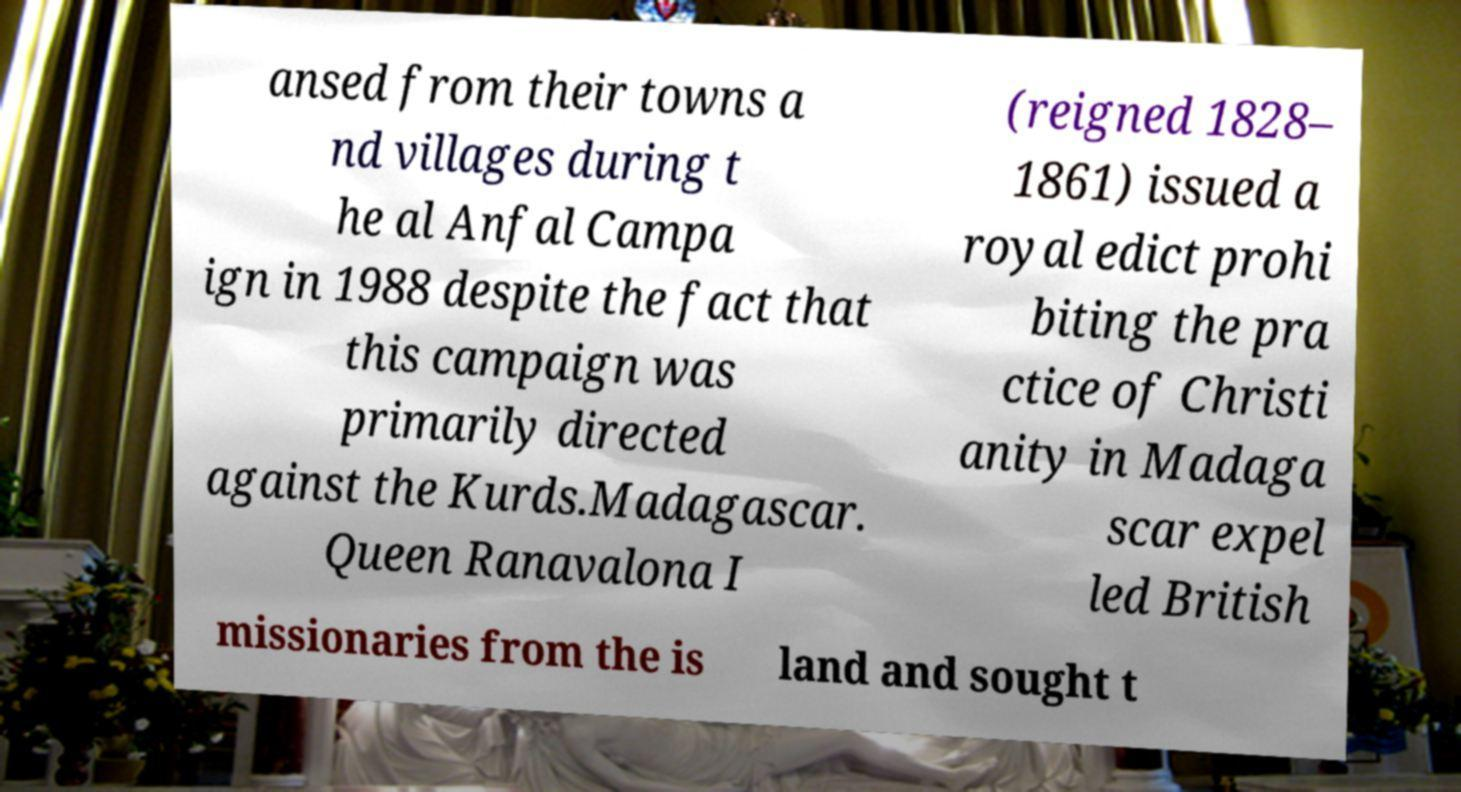For documentation purposes, I need the text within this image transcribed. Could you provide that? ansed from their towns a nd villages during t he al Anfal Campa ign in 1988 despite the fact that this campaign was primarily directed against the Kurds.Madagascar. Queen Ranavalona I (reigned 1828– 1861) issued a royal edict prohi biting the pra ctice of Christi anity in Madaga scar expel led British missionaries from the is land and sought t 